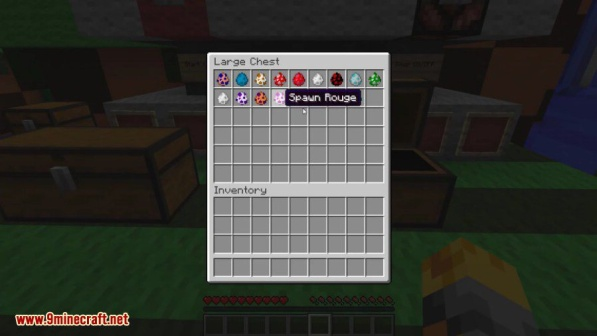Given the minimal personal inventory, what strategies might the player be employing? Considering the minimal personal inventory, the player might be employing several possible strategies. One approach could be meticulous organization—they may have just deposited their items into the chest and are planning their next set of tasks, ensuring they only carry what is necessary. This would help them stay agile and reduce the risk of losing valuable items if they encounter danger.

Another strategy could be that the player is preparing for a specific expedition or mission. For instance, they might plan to gather resources like wood or minerals, so they are keeping their inventory clear to maximize the items they can collect. This approach is particularly useful for resource-intensive tasks that require ample space in the inventory.

It’s also feasible that the player has just respawned and is in the process of re-equipping themselves. In this case, the emptiness in their inventory signifies a moment of preparation, focusing on gathering essential tools and supplies before setting off again.

A more creative strategy might involve the player organizing items for an automated sorting system or preparing to enchant and combine items for more powerful gear. By having an empty inventory, they can systematically arrange their resources and equipment without clutter or confusion. 